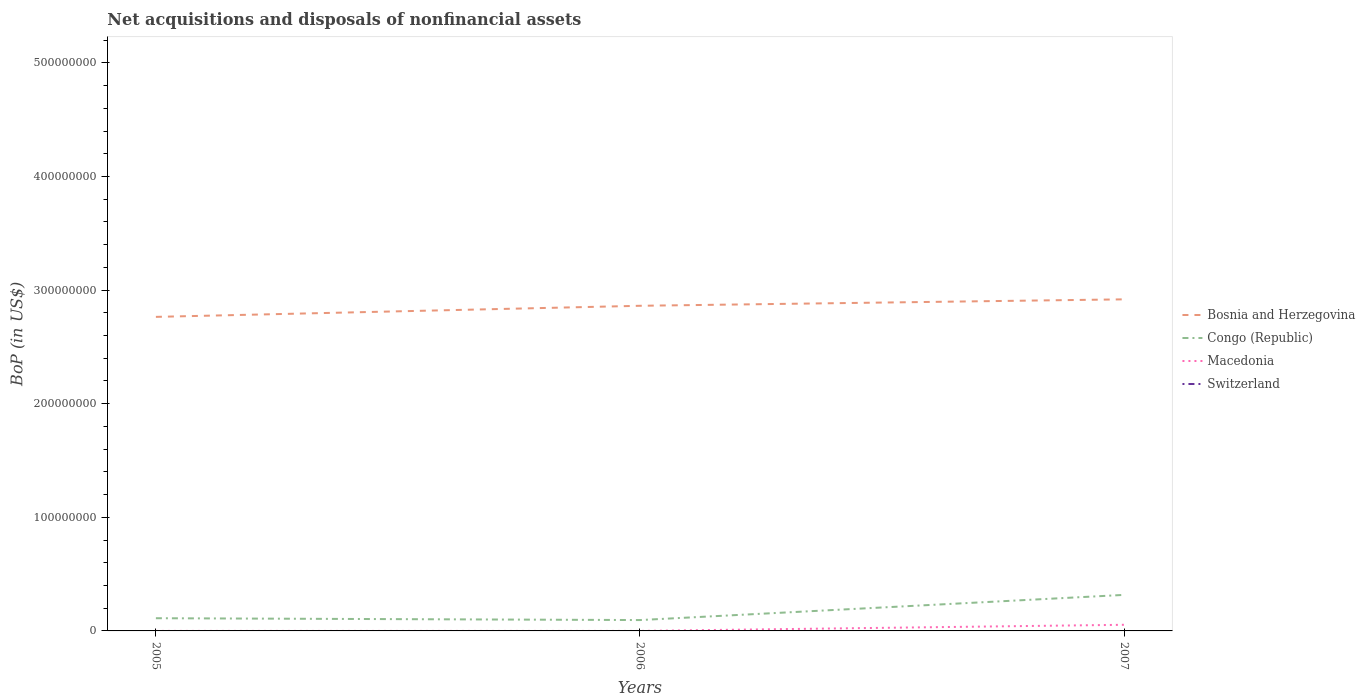Is the number of lines equal to the number of legend labels?
Your response must be concise. No. Across all years, what is the maximum Balance of Payments in Macedonia?
Keep it short and to the point. 4585.23. What is the total Balance of Payments in Congo (Republic) in the graph?
Offer a terse response. -2.22e+07. What is the difference between the highest and the second highest Balance of Payments in Macedonia?
Ensure brevity in your answer.  5.40e+06. Is the Balance of Payments in Switzerland strictly greater than the Balance of Payments in Macedonia over the years?
Keep it short and to the point. Yes. How many lines are there?
Make the answer very short. 3. How many years are there in the graph?
Offer a terse response. 3. What is the difference between two consecutive major ticks on the Y-axis?
Your answer should be very brief. 1.00e+08. Does the graph contain grids?
Make the answer very short. No. Where does the legend appear in the graph?
Give a very brief answer. Center right. How many legend labels are there?
Provide a succinct answer. 4. What is the title of the graph?
Give a very brief answer. Net acquisitions and disposals of nonfinancial assets. What is the label or title of the X-axis?
Provide a short and direct response. Years. What is the label or title of the Y-axis?
Offer a terse response. BoP (in US$). What is the BoP (in US$) in Bosnia and Herzegovina in 2005?
Provide a short and direct response. 2.76e+08. What is the BoP (in US$) in Congo (Republic) in 2005?
Ensure brevity in your answer.  1.12e+07. What is the BoP (in US$) in Macedonia in 2005?
Provide a short and direct response. 7057.87. What is the BoP (in US$) in Bosnia and Herzegovina in 2006?
Ensure brevity in your answer.  2.86e+08. What is the BoP (in US$) in Congo (Republic) in 2006?
Give a very brief answer. 9.56e+06. What is the BoP (in US$) of Macedonia in 2006?
Keep it short and to the point. 4585.23. What is the BoP (in US$) of Bosnia and Herzegovina in 2007?
Your answer should be compact. 2.92e+08. What is the BoP (in US$) of Congo (Republic) in 2007?
Your response must be concise. 3.17e+07. What is the BoP (in US$) of Macedonia in 2007?
Offer a very short reply. 5.40e+06. What is the BoP (in US$) of Switzerland in 2007?
Your answer should be compact. 0. Across all years, what is the maximum BoP (in US$) in Bosnia and Herzegovina?
Your answer should be compact. 2.92e+08. Across all years, what is the maximum BoP (in US$) of Congo (Republic)?
Your answer should be very brief. 3.17e+07. Across all years, what is the maximum BoP (in US$) of Macedonia?
Give a very brief answer. 5.40e+06. Across all years, what is the minimum BoP (in US$) in Bosnia and Herzegovina?
Your answer should be very brief. 2.76e+08. Across all years, what is the minimum BoP (in US$) of Congo (Republic)?
Make the answer very short. 9.56e+06. Across all years, what is the minimum BoP (in US$) of Macedonia?
Ensure brevity in your answer.  4585.23. What is the total BoP (in US$) of Bosnia and Herzegovina in the graph?
Give a very brief answer. 8.55e+08. What is the total BoP (in US$) in Congo (Republic) in the graph?
Your response must be concise. 5.25e+07. What is the total BoP (in US$) of Macedonia in the graph?
Give a very brief answer. 5.41e+06. What is the total BoP (in US$) of Switzerland in the graph?
Provide a succinct answer. 0. What is the difference between the BoP (in US$) in Bosnia and Herzegovina in 2005 and that in 2006?
Keep it short and to the point. -9.77e+06. What is the difference between the BoP (in US$) in Congo (Republic) in 2005 and that in 2006?
Provide a succinct answer. 1.62e+06. What is the difference between the BoP (in US$) in Macedonia in 2005 and that in 2006?
Keep it short and to the point. 2472.64. What is the difference between the BoP (in US$) in Bosnia and Herzegovina in 2005 and that in 2007?
Your answer should be very brief. -1.54e+07. What is the difference between the BoP (in US$) of Congo (Republic) in 2005 and that in 2007?
Keep it short and to the point. -2.05e+07. What is the difference between the BoP (in US$) in Macedonia in 2005 and that in 2007?
Provide a succinct answer. -5.39e+06. What is the difference between the BoP (in US$) in Bosnia and Herzegovina in 2006 and that in 2007?
Ensure brevity in your answer.  -5.67e+06. What is the difference between the BoP (in US$) of Congo (Republic) in 2006 and that in 2007?
Your response must be concise. -2.22e+07. What is the difference between the BoP (in US$) of Macedonia in 2006 and that in 2007?
Keep it short and to the point. -5.40e+06. What is the difference between the BoP (in US$) of Bosnia and Herzegovina in 2005 and the BoP (in US$) of Congo (Republic) in 2006?
Your response must be concise. 2.67e+08. What is the difference between the BoP (in US$) in Bosnia and Herzegovina in 2005 and the BoP (in US$) in Macedonia in 2006?
Ensure brevity in your answer.  2.76e+08. What is the difference between the BoP (in US$) of Congo (Republic) in 2005 and the BoP (in US$) of Macedonia in 2006?
Offer a very short reply. 1.12e+07. What is the difference between the BoP (in US$) of Bosnia and Herzegovina in 2005 and the BoP (in US$) of Congo (Republic) in 2007?
Ensure brevity in your answer.  2.45e+08. What is the difference between the BoP (in US$) in Bosnia and Herzegovina in 2005 and the BoP (in US$) in Macedonia in 2007?
Provide a succinct answer. 2.71e+08. What is the difference between the BoP (in US$) in Congo (Republic) in 2005 and the BoP (in US$) in Macedonia in 2007?
Keep it short and to the point. 5.79e+06. What is the difference between the BoP (in US$) of Bosnia and Herzegovina in 2006 and the BoP (in US$) of Congo (Republic) in 2007?
Your answer should be compact. 2.54e+08. What is the difference between the BoP (in US$) in Bosnia and Herzegovina in 2006 and the BoP (in US$) in Macedonia in 2007?
Provide a succinct answer. 2.81e+08. What is the difference between the BoP (in US$) of Congo (Republic) in 2006 and the BoP (in US$) of Macedonia in 2007?
Make the answer very short. 4.16e+06. What is the average BoP (in US$) in Bosnia and Herzegovina per year?
Offer a very short reply. 2.85e+08. What is the average BoP (in US$) of Congo (Republic) per year?
Make the answer very short. 1.75e+07. What is the average BoP (in US$) in Macedonia per year?
Offer a terse response. 1.80e+06. In the year 2005, what is the difference between the BoP (in US$) of Bosnia and Herzegovina and BoP (in US$) of Congo (Republic)?
Make the answer very short. 2.65e+08. In the year 2005, what is the difference between the BoP (in US$) of Bosnia and Herzegovina and BoP (in US$) of Macedonia?
Your answer should be very brief. 2.76e+08. In the year 2005, what is the difference between the BoP (in US$) of Congo (Republic) and BoP (in US$) of Macedonia?
Provide a succinct answer. 1.12e+07. In the year 2006, what is the difference between the BoP (in US$) of Bosnia and Herzegovina and BoP (in US$) of Congo (Republic)?
Keep it short and to the point. 2.77e+08. In the year 2006, what is the difference between the BoP (in US$) in Bosnia and Herzegovina and BoP (in US$) in Macedonia?
Ensure brevity in your answer.  2.86e+08. In the year 2006, what is the difference between the BoP (in US$) of Congo (Republic) and BoP (in US$) of Macedonia?
Your answer should be compact. 9.56e+06. In the year 2007, what is the difference between the BoP (in US$) of Bosnia and Herzegovina and BoP (in US$) of Congo (Republic)?
Keep it short and to the point. 2.60e+08. In the year 2007, what is the difference between the BoP (in US$) in Bosnia and Herzegovina and BoP (in US$) in Macedonia?
Keep it short and to the point. 2.86e+08. In the year 2007, what is the difference between the BoP (in US$) in Congo (Republic) and BoP (in US$) in Macedonia?
Your answer should be compact. 2.63e+07. What is the ratio of the BoP (in US$) in Bosnia and Herzegovina in 2005 to that in 2006?
Your response must be concise. 0.97. What is the ratio of the BoP (in US$) in Congo (Republic) in 2005 to that in 2006?
Your answer should be compact. 1.17. What is the ratio of the BoP (in US$) of Macedonia in 2005 to that in 2006?
Ensure brevity in your answer.  1.54. What is the ratio of the BoP (in US$) of Bosnia and Herzegovina in 2005 to that in 2007?
Your answer should be very brief. 0.95. What is the ratio of the BoP (in US$) in Congo (Republic) in 2005 to that in 2007?
Provide a short and direct response. 0.35. What is the ratio of the BoP (in US$) of Macedonia in 2005 to that in 2007?
Your answer should be very brief. 0. What is the ratio of the BoP (in US$) in Bosnia and Herzegovina in 2006 to that in 2007?
Your answer should be compact. 0.98. What is the ratio of the BoP (in US$) of Congo (Republic) in 2006 to that in 2007?
Give a very brief answer. 0.3. What is the ratio of the BoP (in US$) of Macedonia in 2006 to that in 2007?
Offer a terse response. 0. What is the difference between the highest and the second highest BoP (in US$) in Bosnia and Herzegovina?
Ensure brevity in your answer.  5.67e+06. What is the difference between the highest and the second highest BoP (in US$) of Congo (Republic)?
Offer a very short reply. 2.05e+07. What is the difference between the highest and the second highest BoP (in US$) in Macedonia?
Your answer should be very brief. 5.39e+06. What is the difference between the highest and the lowest BoP (in US$) in Bosnia and Herzegovina?
Make the answer very short. 1.54e+07. What is the difference between the highest and the lowest BoP (in US$) of Congo (Republic)?
Offer a terse response. 2.22e+07. What is the difference between the highest and the lowest BoP (in US$) in Macedonia?
Ensure brevity in your answer.  5.40e+06. 